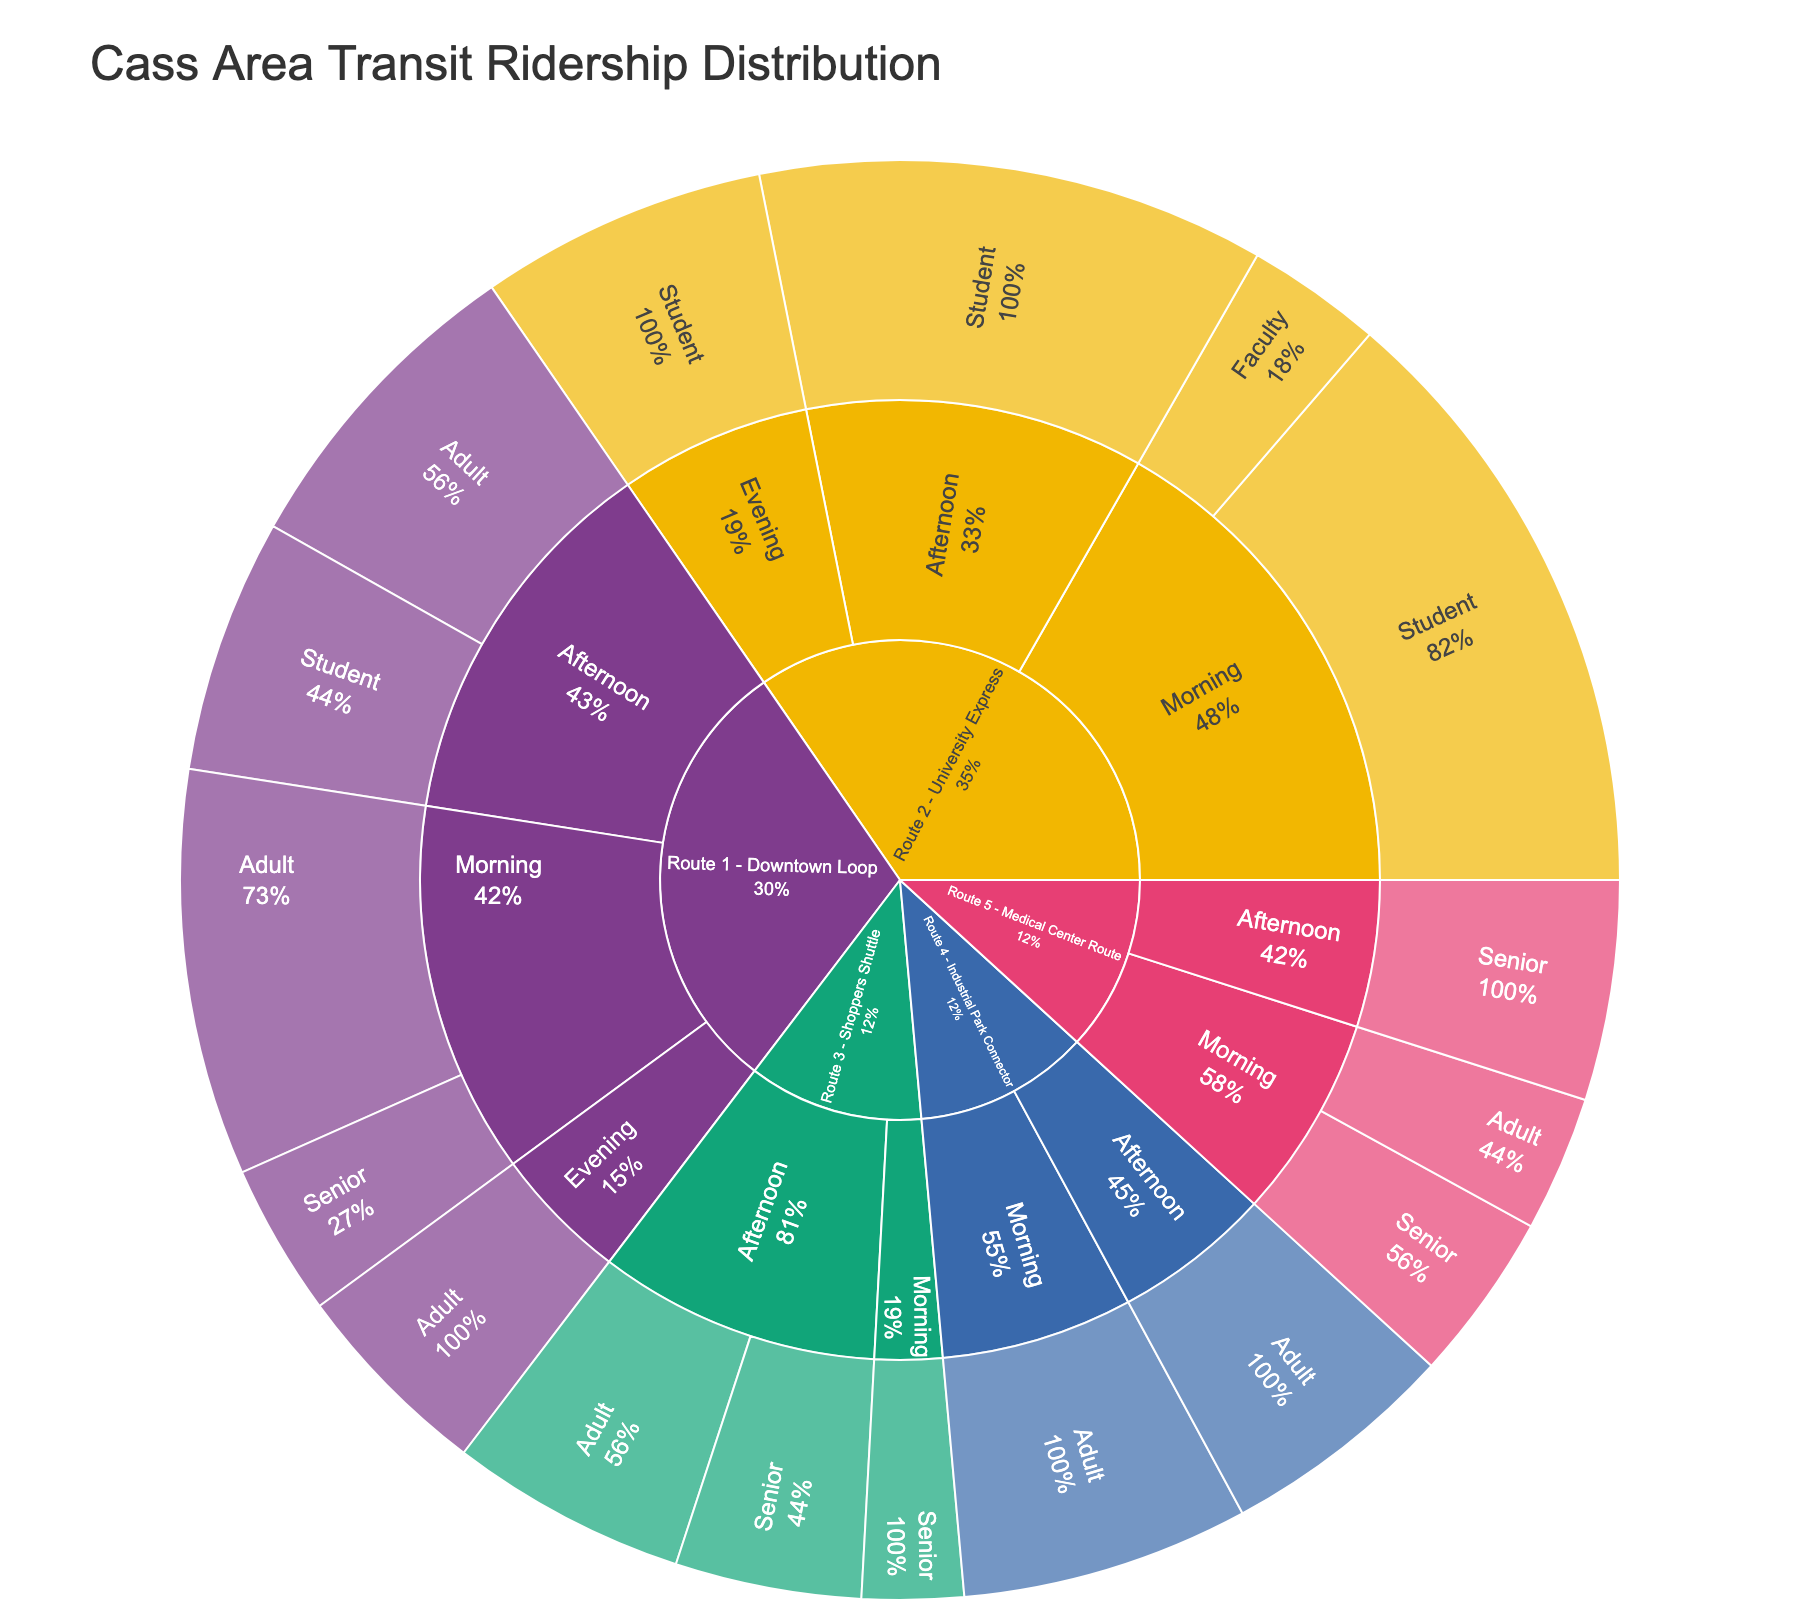what is the title of the diagram? The title can be found at the top of the figure. It generally provides a concise summary of what the figure represents.
Answer: Cass Area Transit Ridership Distribution Which route has the highest number of morning riders? To find the answer, look for the largest segment within the morning category in the Sunburst Plot.
Answer: Route 2 - University Express How many senior riders are there on Route 5 - Medical Center Route in the afternoon? The plot details the number of riders for each category. Locate the segment under Route 5, then the afternoon, and finally seniors.
Answer: 65 riders Compare the number of adult riders in the afternoon for Route 1 - Downtown Loop and Route 4 - Industrial Park Connector. Which route has more riders and by how much? Identify the segments for adult riders in the afternoon for both routes and compare the values.
Answer: Route 1 has 95 adult riders and Route 4 has 70, so Route 1 has 25 more adult riders What percentage of total riders for Route 1 - Downtown Loop ride in the morning? First, find the total number of riders for Route 1 by summing all its segments. Then, determine the number of morning riders and calculate their percentage of the total.
Answer: (120 + 45) / (120 + 45 + 95 + 75 + 60) = 165 / 395 ≈ 41.8% How does the ridership of Route 3's morning seniors compare to its afternoon seniors? Look at the values for senior riders in the morning and afternoon for Route 3 and perform the comparison.
Answer: Morning: 30, Afternoon: 55, so the afternoon has 25 more senior riders Which demographic group has the most riders on Route 2 - University Express? Identify the segments under Route 2 and compare the values for each demographic. The largest segment represents the group with the most riders.
Answer: Student What is the total number of riders for Route 4 - Industrial Park Connector? Sum the number of riders for all its segments as shown in the plot.
Answer: 85 (morning) + 70 (afternoon) = 155 Compare the overall senior ridership to student ridership. Which demographic has more riders and by how much? Sum the total riders for seniors across all routes and do the same for students, then compare the two sums.
Answer: Seniors: 45 + 30 + 55 + 50 + 65 = 245, Students: 75 + 180 + 150 + 85 = 490; Students have 245 more riders How is the ridership distributed across the time of day for Route 2 - University Express? Break down the number of riders by each time of day segment under Route 2 to see the distribution.
Answer: Morning: 220, Afternoon: 150, Evening: 85 